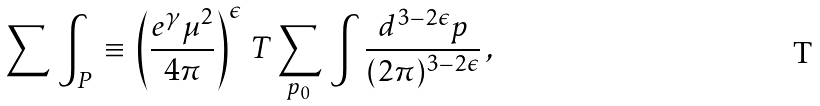Convert formula to latex. <formula><loc_0><loc_0><loc_500><loc_500>\sum \, \int _ { P } \, \equiv \, \left ( \frac { e ^ { \gamma } \mu ^ { 2 } } { 4 \pi } \right ) ^ { \epsilon } \, T \sum _ { p _ { 0 } } \, \int { \frac { d ^ { 3 - 2 \epsilon } p } { ( 2 \pi ) ^ { 3 - 2 \epsilon } } } \, ,</formula> 